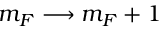Convert formula to latex. <formula><loc_0><loc_0><loc_500><loc_500>m _ { F } \longrightarrow m _ { F } + 1</formula> 